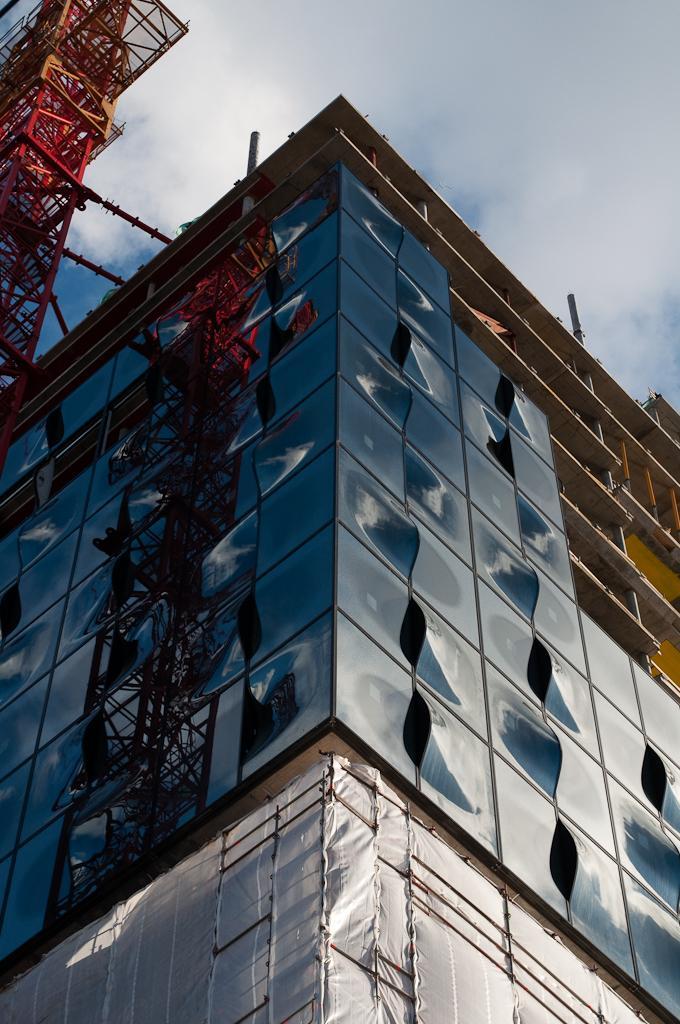Can you describe this image briefly? In the foreground of this image, there is a glass building and on the left top, there is a tower and sky and the cloud on the top. 